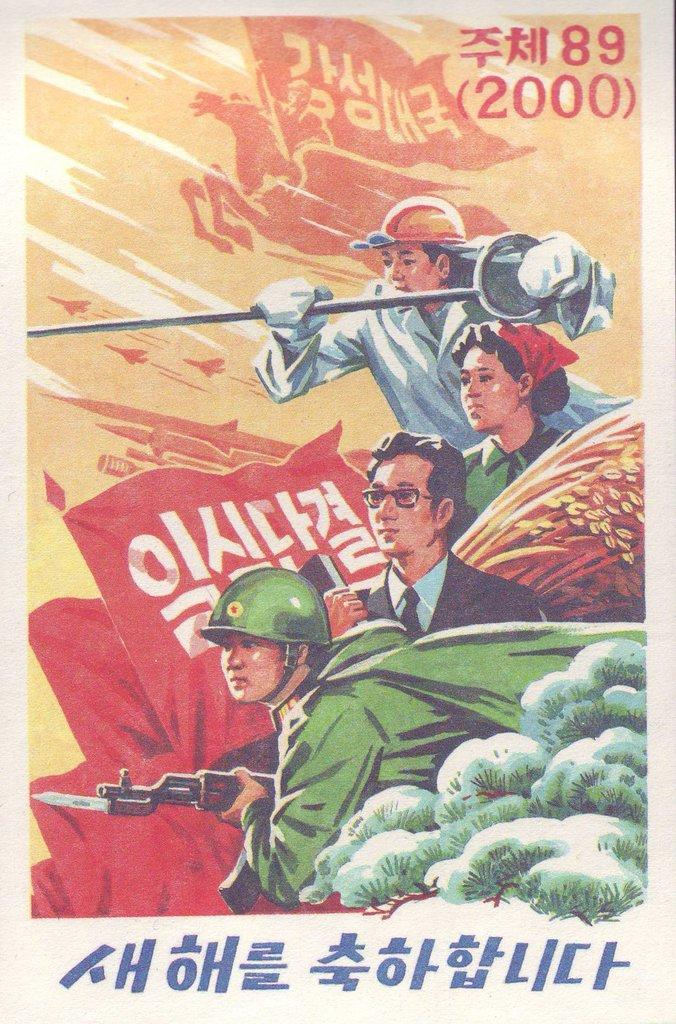Provide a one-sentence caption for the provided image. A poster with foreign characters on it that also has the numbers 89 and 2000 in the top right corner. 